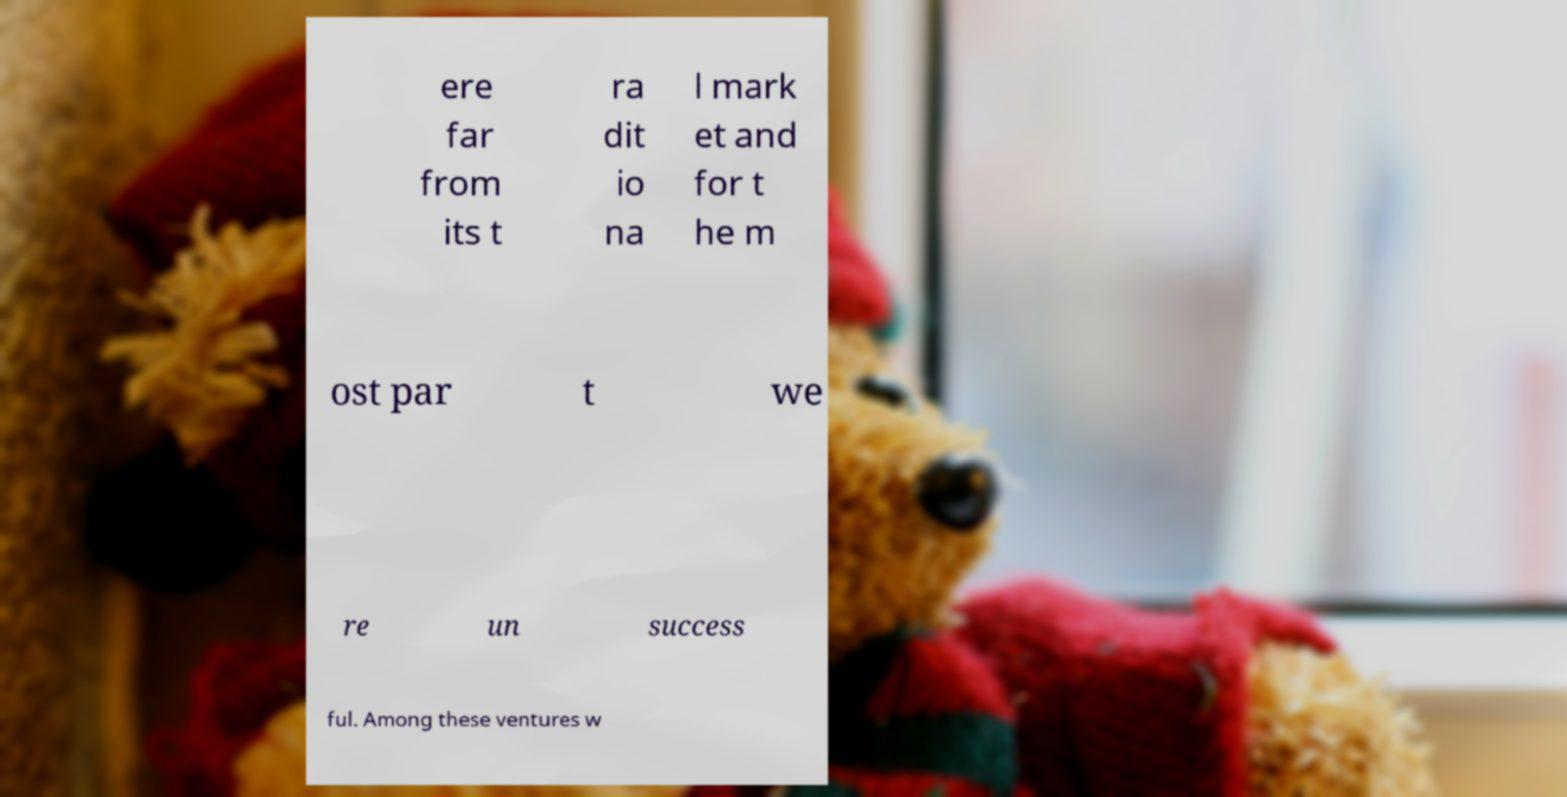Please identify and transcribe the text found in this image. ere far from its t ra dit io na l mark et and for t he m ost par t we re un success ful. Among these ventures w 